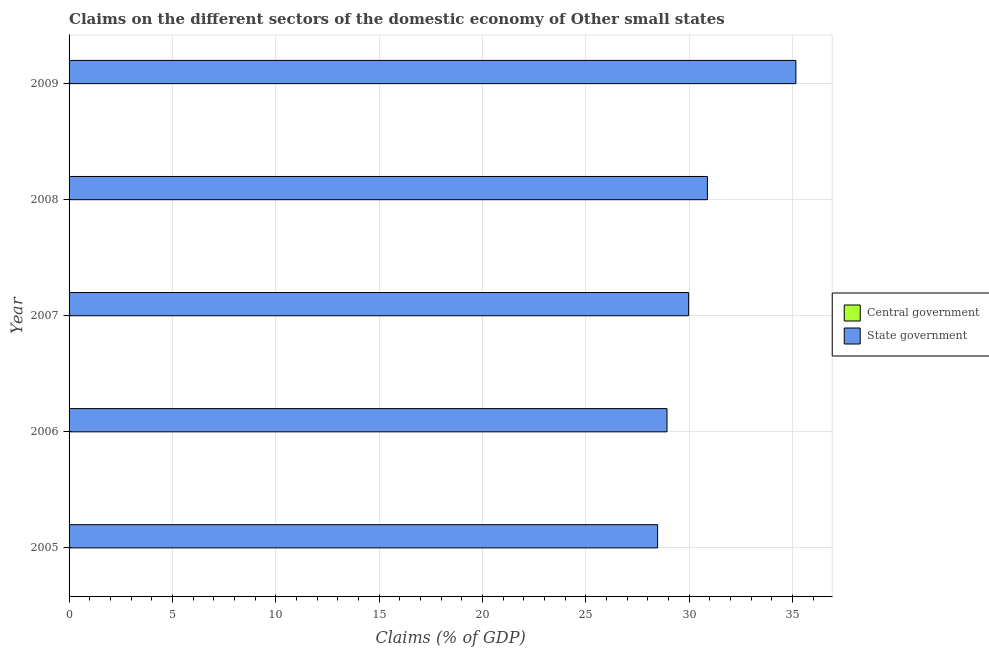How many bars are there on the 1st tick from the top?
Offer a terse response. 1. How many bars are there on the 2nd tick from the bottom?
Offer a very short reply. 1. In how many cases, is the number of bars for a given year not equal to the number of legend labels?
Your answer should be compact. 5. Across all years, what is the maximum claims on state government?
Make the answer very short. 35.17. What is the total claims on state government in the graph?
Give a very brief answer. 153.46. What is the difference between the claims on state government in 2007 and that in 2008?
Your response must be concise. -0.91. What is the difference between the claims on state government in 2009 and the claims on central government in 2008?
Your answer should be very brief. 35.17. What is the average claims on state government per year?
Ensure brevity in your answer.  30.69. In how many years, is the claims on central government greater than 35 %?
Offer a terse response. 0. What is the ratio of the claims on state government in 2006 to that in 2009?
Give a very brief answer. 0.82. What is the difference between the highest and the second highest claims on state government?
Provide a succinct answer. 4.28. What is the difference between the highest and the lowest claims on state government?
Your response must be concise. 6.69. Is the sum of the claims on state government in 2005 and 2009 greater than the maximum claims on central government across all years?
Provide a short and direct response. Yes. Are all the bars in the graph horizontal?
Your answer should be very brief. Yes. How many years are there in the graph?
Provide a short and direct response. 5. Are the values on the major ticks of X-axis written in scientific E-notation?
Make the answer very short. No. Does the graph contain any zero values?
Offer a very short reply. Yes. Does the graph contain grids?
Give a very brief answer. Yes. Where does the legend appear in the graph?
Offer a very short reply. Center right. What is the title of the graph?
Provide a short and direct response. Claims on the different sectors of the domestic economy of Other small states. Does "Old" appear as one of the legend labels in the graph?
Provide a short and direct response. No. What is the label or title of the X-axis?
Your answer should be very brief. Claims (% of GDP). What is the Claims (% of GDP) of Central government in 2005?
Your response must be concise. 0. What is the Claims (% of GDP) in State government in 2005?
Offer a very short reply. 28.48. What is the Claims (% of GDP) of State government in 2006?
Provide a short and direct response. 28.93. What is the Claims (% of GDP) in State government in 2007?
Give a very brief answer. 29.98. What is the Claims (% of GDP) of State government in 2008?
Provide a succinct answer. 30.89. What is the Claims (% of GDP) in State government in 2009?
Offer a terse response. 35.17. Across all years, what is the maximum Claims (% of GDP) of State government?
Your answer should be very brief. 35.17. Across all years, what is the minimum Claims (% of GDP) of State government?
Provide a succinct answer. 28.48. What is the total Claims (% of GDP) in Central government in the graph?
Your response must be concise. 0. What is the total Claims (% of GDP) of State government in the graph?
Give a very brief answer. 153.46. What is the difference between the Claims (% of GDP) in State government in 2005 and that in 2006?
Keep it short and to the point. -0.45. What is the difference between the Claims (% of GDP) in State government in 2005 and that in 2007?
Keep it short and to the point. -1.5. What is the difference between the Claims (% of GDP) in State government in 2005 and that in 2008?
Keep it short and to the point. -2.41. What is the difference between the Claims (% of GDP) of State government in 2005 and that in 2009?
Your response must be concise. -6.69. What is the difference between the Claims (% of GDP) in State government in 2006 and that in 2007?
Give a very brief answer. -1.04. What is the difference between the Claims (% of GDP) of State government in 2006 and that in 2008?
Your answer should be compact. -1.95. What is the difference between the Claims (% of GDP) of State government in 2006 and that in 2009?
Your response must be concise. -6.24. What is the difference between the Claims (% of GDP) in State government in 2007 and that in 2008?
Offer a terse response. -0.91. What is the difference between the Claims (% of GDP) of State government in 2007 and that in 2009?
Offer a terse response. -5.19. What is the difference between the Claims (% of GDP) of State government in 2008 and that in 2009?
Ensure brevity in your answer.  -4.28. What is the average Claims (% of GDP) in Central government per year?
Your response must be concise. 0. What is the average Claims (% of GDP) of State government per year?
Give a very brief answer. 30.69. What is the ratio of the Claims (% of GDP) in State government in 2005 to that in 2006?
Provide a short and direct response. 0.98. What is the ratio of the Claims (% of GDP) of State government in 2005 to that in 2007?
Offer a terse response. 0.95. What is the ratio of the Claims (% of GDP) of State government in 2005 to that in 2008?
Your answer should be very brief. 0.92. What is the ratio of the Claims (% of GDP) of State government in 2005 to that in 2009?
Give a very brief answer. 0.81. What is the ratio of the Claims (% of GDP) of State government in 2006 to that in 2007?
Keep it short and to the point. 0.97. What is the ratio of the Claims (% of GDP) of State government in 2006 to that in 2008?
Give a very brief answer. 0.94. What is the ratio of the Claims (% of GDP) of State government in 2006 to that in 2009?
Make the answer very short. 0.82. What is the ratio of the Claims (% of GDP) of State government in 2007 to that in 2008?
Make the answer very short. 0.97. What is the ratio of the Claims (% of GDP) in State government in 2007 to that in 2009?
Your response must be concise. 0.85. What is the ratio of the Claims (% of GDP) of State government in 2008 to that in 2009?
Your answer should be very brief. 0.88. What is the difference between the highest and the second highest Claims (% of GDP) in State government?
Offer a very short reply. 4.28. What is the difference between the highest and the lowest Claims (% of GDP) in State government?
Ensure brevity in your answer.  6.69. 